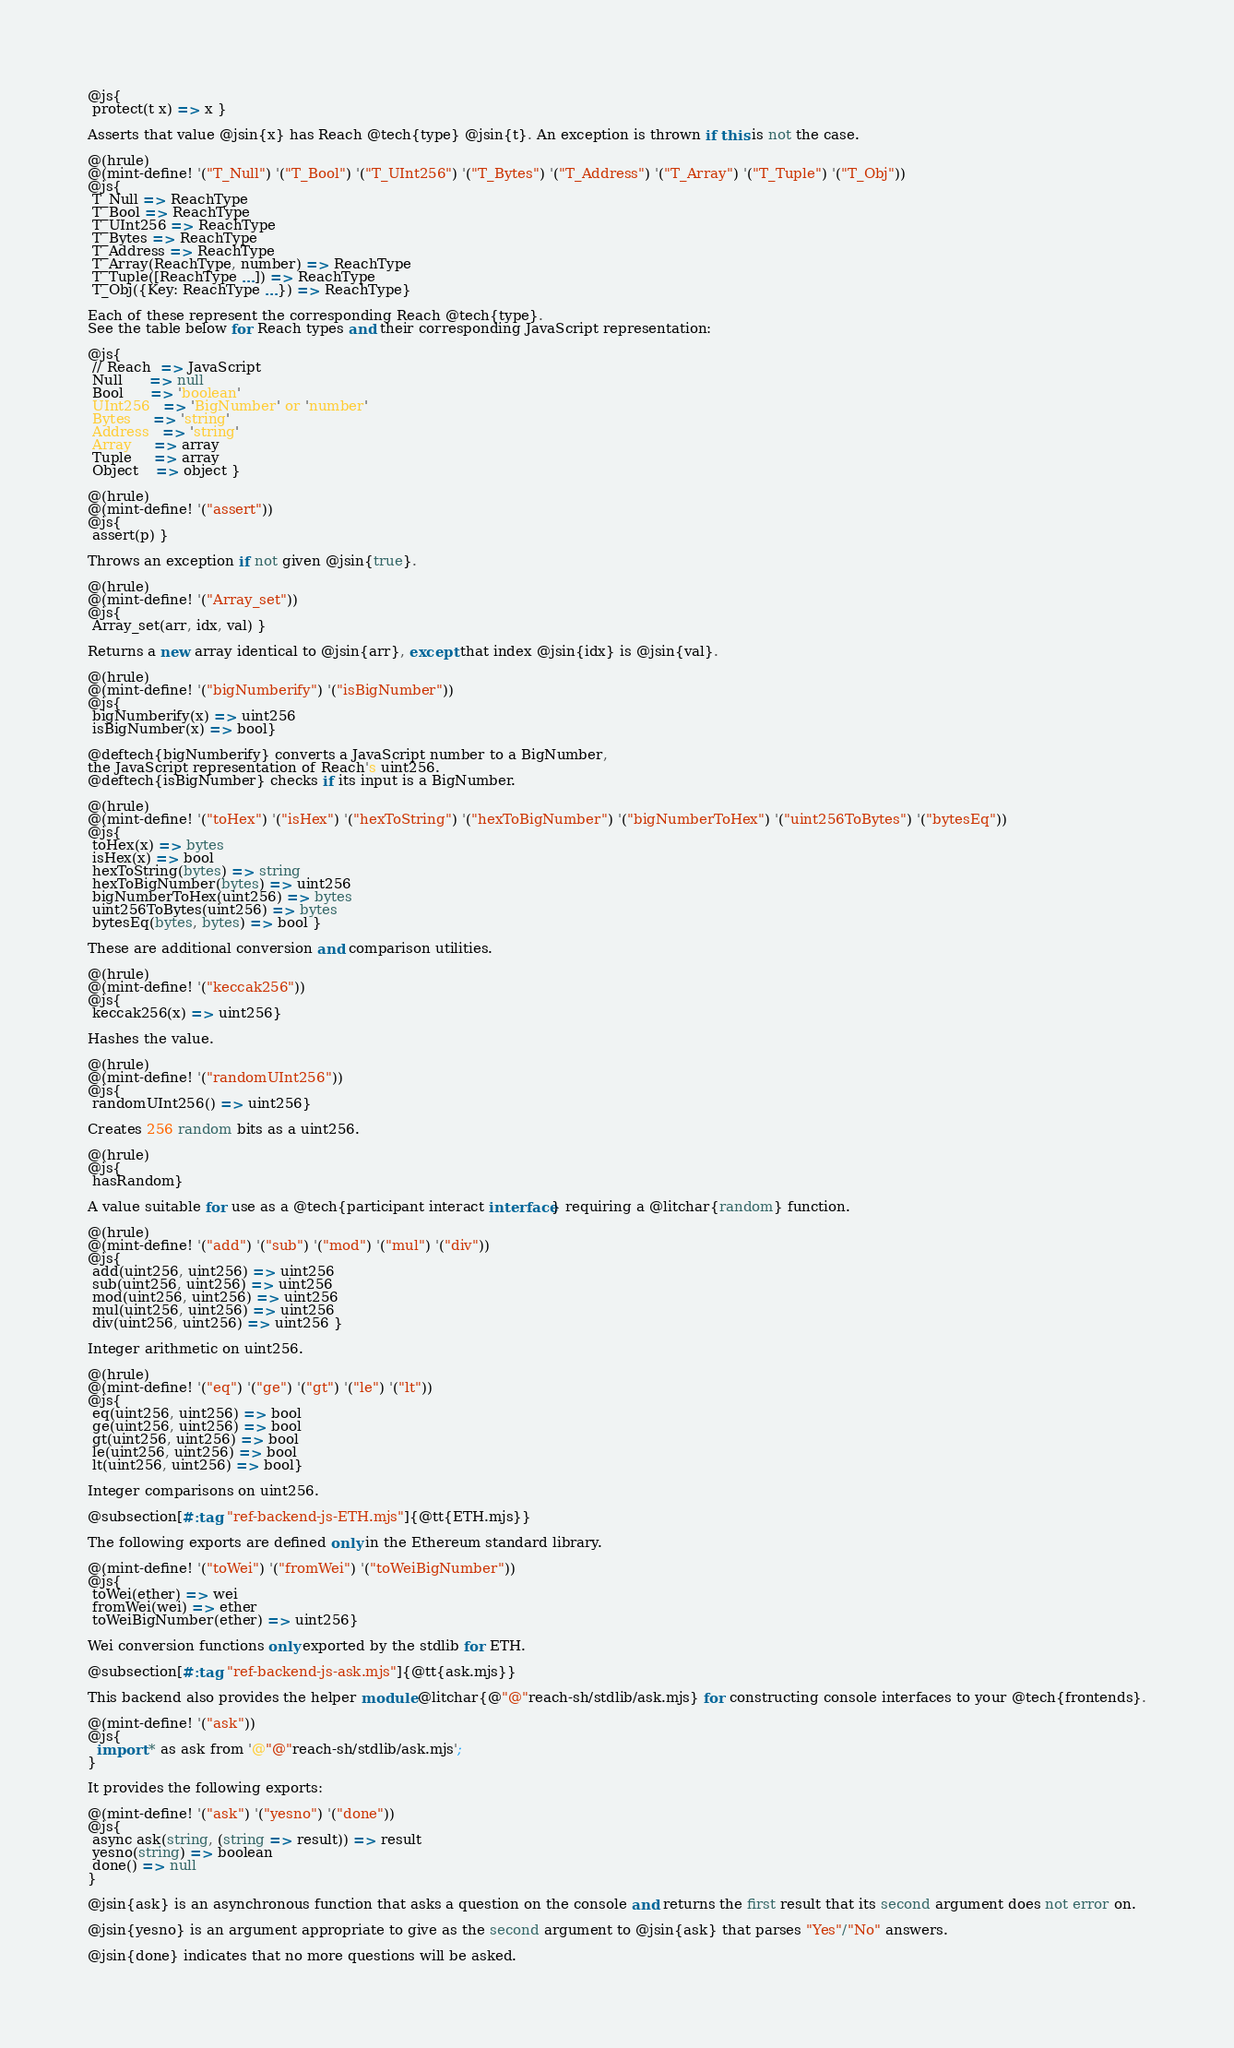Convert code to text. <code><loc_0><loc_0><loc_500><loc_500><_Racket_>@js{
 protect(t x) => x }

Asserts that value @jsin{x} has Reach @tech{type} @jsin{t}. An exception is thrown if this is not the case.

@(hrule)
@(mint-define! '("T_Null") '("T_Bool") '("T_UInt256") '("T_Bytes") '("T_Address") '("T_Array") '("T_Tuple") '("T_Obj"))
@js{
 T_Null => ReachType
 T_Bool => ReachType
 T_UInt256 => ReachType
 T_Bytes => ReachType
 T_Address => ReachType
 T_Array(ReachType, number) => ReachType
 T_Tuple([ReachType ...]) => ReachType
 T_Obj({Key: ReachType ...}) => ReachType}

Each of these represent the corresponding Reach @tech{type}.
See the table below for Reach types and their corresponding JavaScript representation:

@js{
 // Reach  => JavaScript
 Null      => null
 Bool      => 'boolean'
 UInt256   => 'BigNumber' or 'number'
 Bytes     => 'string'
 Address   => 'string'
 Array     => array
 Tuple     => array
 Object    => object }

@(hrule)
@(mint-define! '("assert"))
@js{
 assert(p) }

Throws an exception if not given @jsin{true}.

@(hrule)
@(mint-define! '("Array_set"))
@js{
 Array_set(arr, idx, val) }

Returns a new array identical to @jsin{arr}, except that index @jsin{idx} is @jsin{val}.

@(hrule)
@(mint-define! '("bigNumberify") '("isBigNumber"))
@js{
 bigNumberify(x) => uint256
 isBigNumber(x) => bool}

@deftech{bigNumberify} converts a JavaScript number to a BigNumber,
the JavaScript representation of Reach's uint256.
@deftech{isBigNumber} checks if its input is a BigNumber.

@(hrule)
@(mint-define! '("toHex") '("isHex") '("hexToString") '("hexToBigNumber") '("bigNumberToHex") '("uint256ToBytes") '("bytesEq"))
@js{
 toHex(x) => bytes
 isHex(x) => bool
 hexToString(bytes) => string
 hexToBigNumber(bytes) => uint256
 bigNumberToHex(uint256) => bytes
 uint256ToBytes(uint256) => bytes
 bytesEq(bytes, bytes) => bool }

These are additional conversion and comparison utilities.

@(hrule)
@(mint-define! '("keccak256"))
@js{
 keccak256(x) => uint256}

Hashes the value.

@(hrule)
@(mint-define! '("randomUInt256"))
@js{
 randomUInt256() => uint256}

Creates 256 random bits as a uint256.

@(hrule)
@js{
 hasRandom}

A value suitable for use as a @tech{participant interact interface} requiring a @litchar{random} function.

@(hrule)
@(mint-define! '("add") '("sub") '("mod") '("mul") '("div"))
@js{
 add(uint256, uint256) => uint256
 sub(uint256, uint256) => uint256
 mod(uint256, uint256) => uint256
 mul(uint256, uint256) => uint256
 div(uint256, uint256) => uint256 }

Integer arithmetic on uint256.

@(hrule)
@(mint-define! '("eq") '("ge") '("gt") '("le") '("lt"))
@js{
 eq(uint256, uint256) => bool
 ge(uint256, uint256) => bool
 gt(uint256, uint256) => bool
 le(uint256, uint256) => bool
 lt(uint256, uint256) => bool}

Integer comparisons on uint256.

@subsection[#:tag "ref-backend-js-ETH.mjs"]{@tt{ETH.mjs}}

The following exports are defined only in the Ethereum standard library.

@(mint-define! '("toWei") '("fromWei") '("toWeiBigNumber"))
@js{
 toWei(ether) => wei
 fromWei(wei) => ether
 toWeiBigNumber(ether) => uint256}

Wei conversion functions only exported by the stdlib for ETH.

@subsection[#:tag "ref-backend-js-ask.mjs"]{@tt{ask.mjs}}

This backend also provides the helper module @litchar{@"@"reach-sh/stdlib/ask.mjs} for constructing console interfaces to your @tech{frontends}.

@(mint-define! '("ask"))
@js{
  import * as ask from '@"@"reach-sh/stdlib/ask.mjs';
}

It provides the following exports:

@(mint-define! '("ask") '("yesno") '("done"))
@js{
 async ask(string, (string => result)) => result
 yesno(string) => boolean
 done() => null
}
 
@jsin{ask} is an asynchronous function that asks a question on the console and returns the first result that its second argument does not error on.

@jsin{yesno} is an argument appropriate to give as the second argument to @jsin{ask} that parses "Yes"/"No" answers.

@jsin{done} indicates that no more questions will be asked.
</code> 